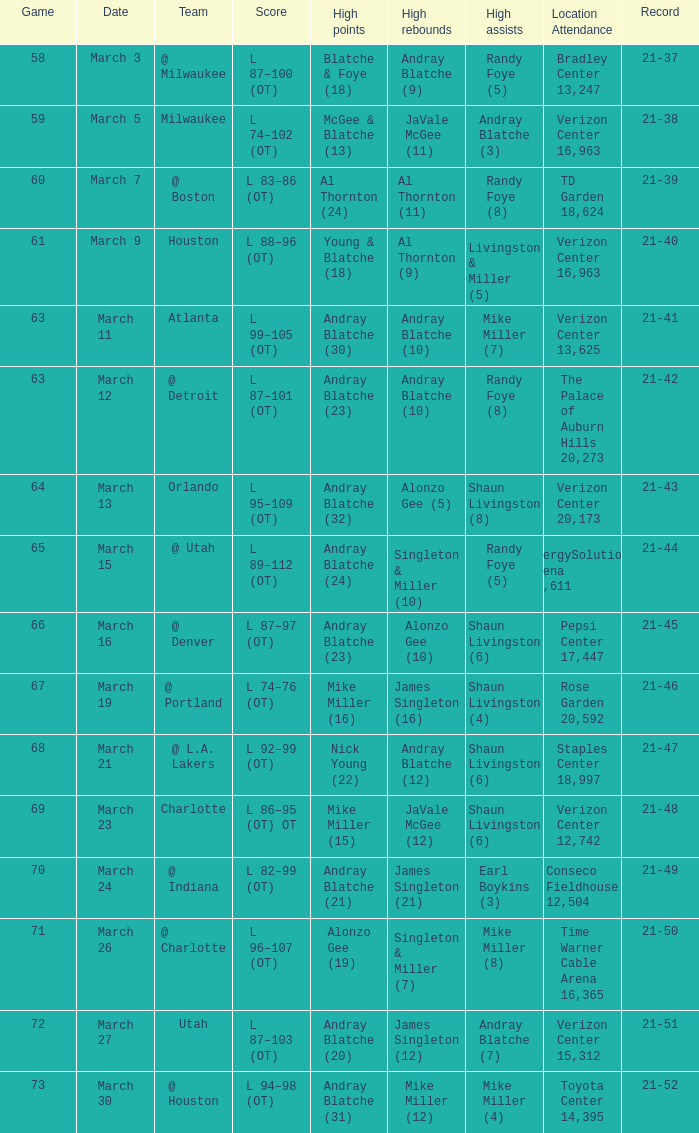When was the attendance at td garden recorded as 18,624? March 7. 